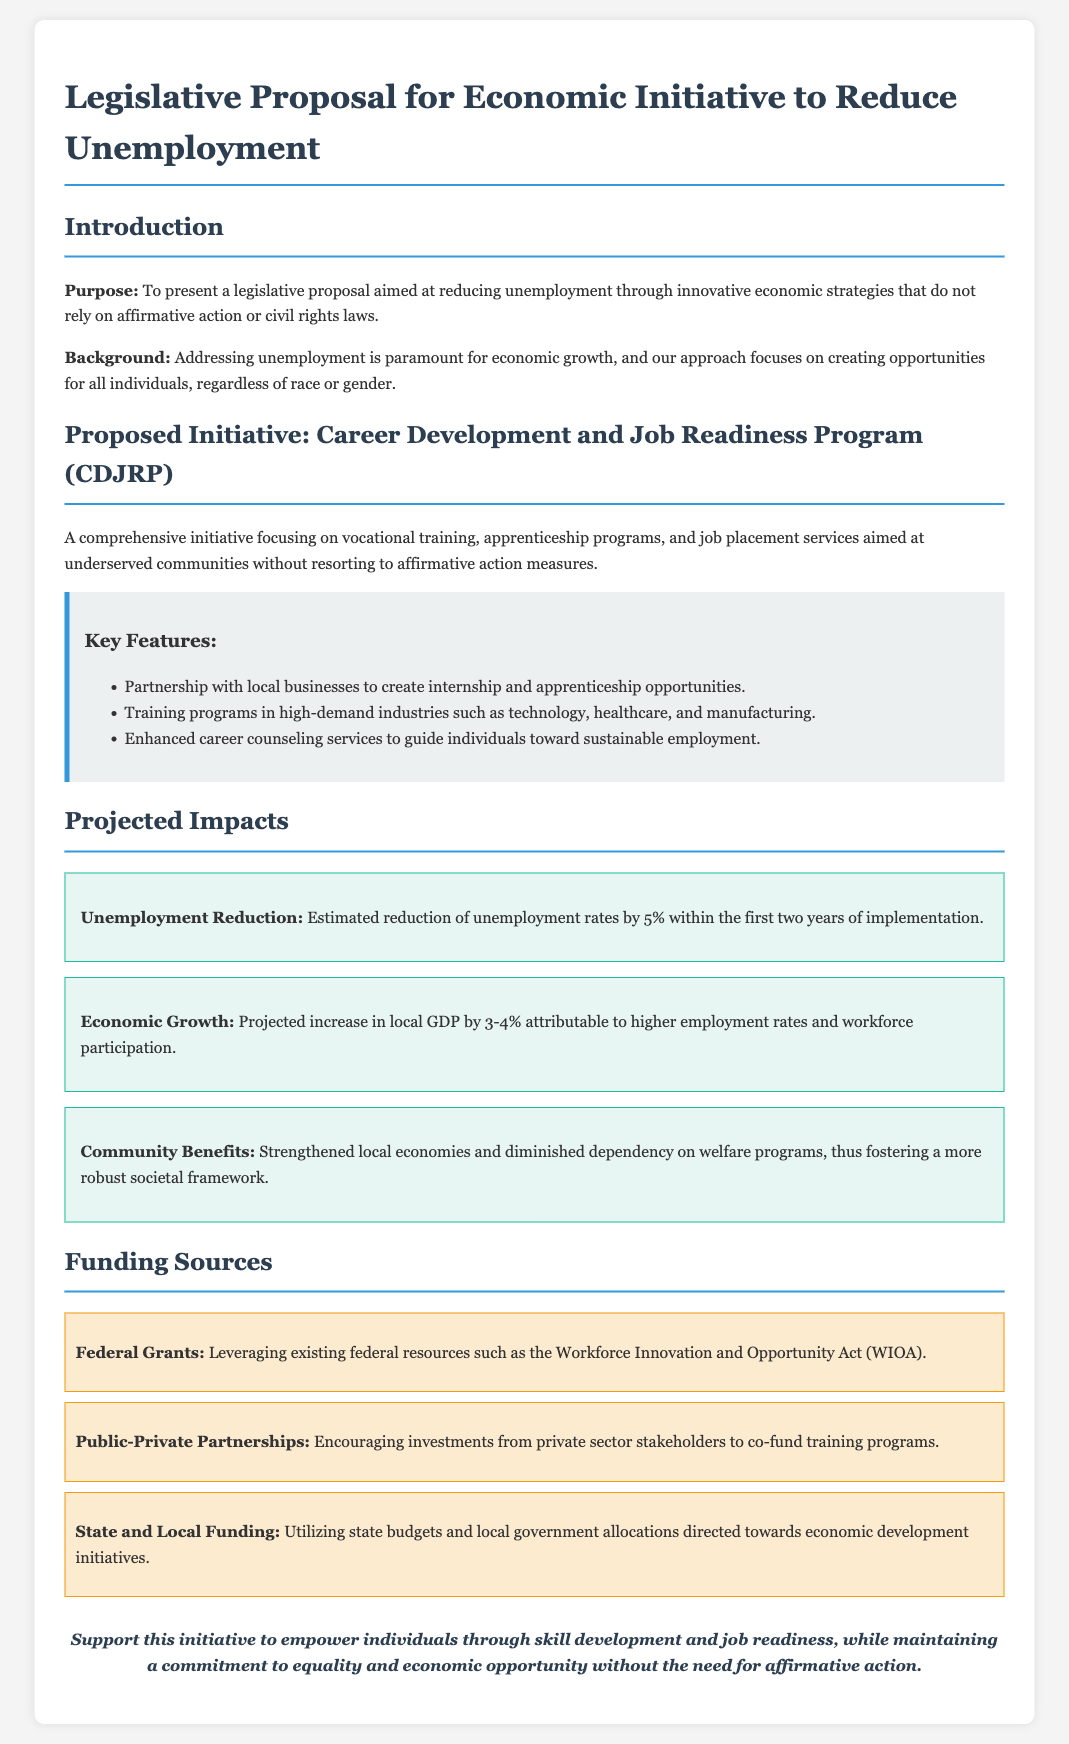what is the purpose of the legislative proposal? The purpose is to present a legislative proposal aimed at reducing unemployment through innovative economic strategies that do not rely on affirmative action or civil rights laws.
Answer: to reduce unemployment without affirmative action what initiative is proposed in the document? The document proposes the Career Development and Job Readiness Program (CDJRP).
Answer: Career Development and Job Readiness Program (CDJRP) how much is the estimated reduction of unemployment rates? The estimated reduction of unemployment rates is by 5% within the first two years of implementation.
Answer: 5% what are the projected community benefits mentioned? The projected community benefits include strengthened local economies and diminished dependency on welfare programs.
Answer: strengthened local economies and diminished dependency on welfare programs what is one of the funding sources listed in the document? One of the funding sources listed is Federal Grants.
Answer: Federal Grants how much is the projected increase in local GDP? The projected increase in local GDP is by 3-4%.
Answer: 3-4% what types of training programs are included in the initiative? The initiative includes training programs in high-demand industries such as technology, healthcare, and manufacturing.
Answer: technology, healthcare, and manufacturing who will the initiative partner with for internship opportunities? The initiative will partner with local businesses.
Answer: local businesses 